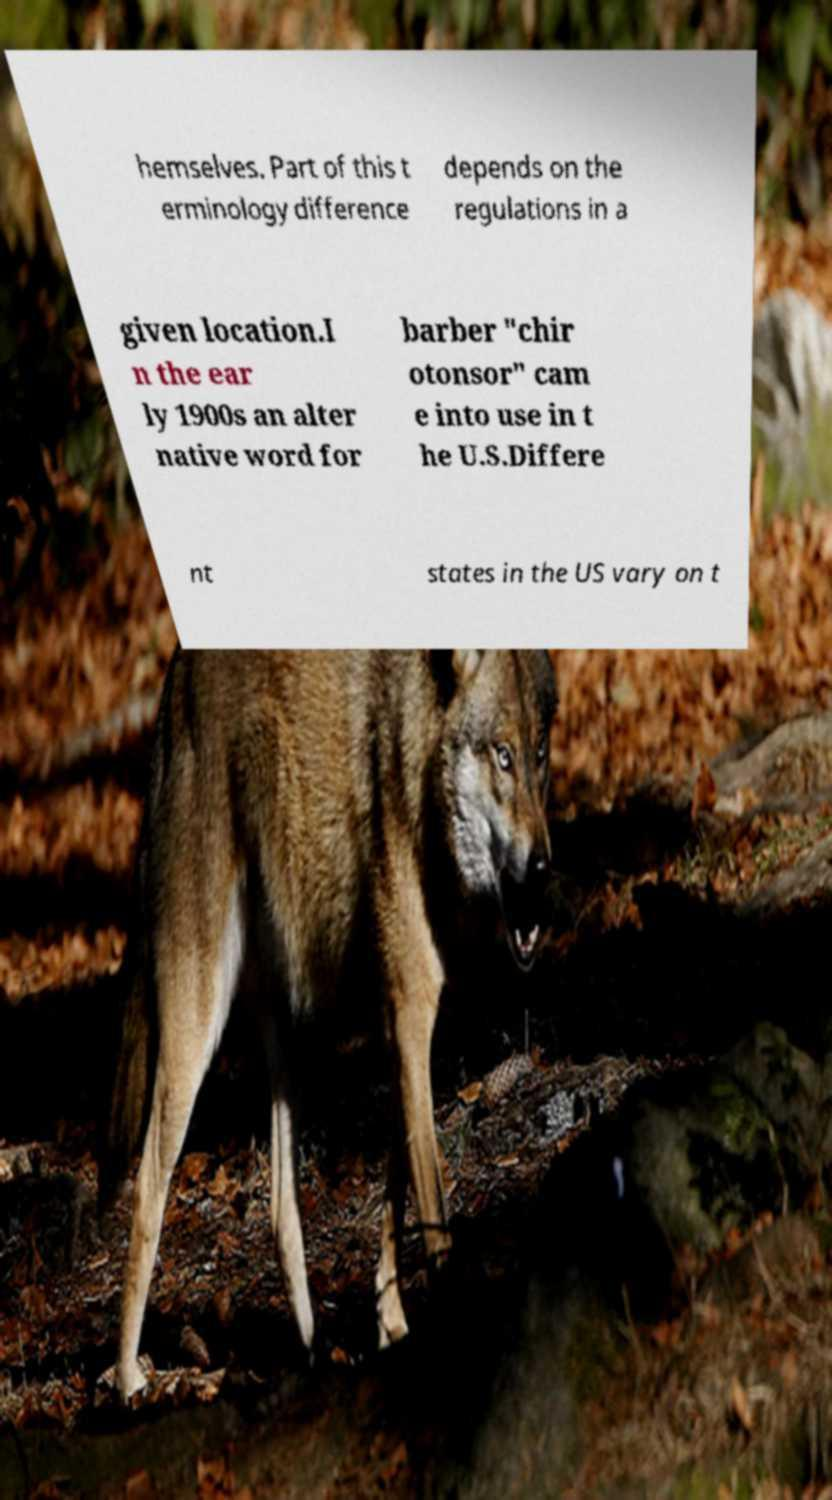Can you accurately transcribe the text from the provided image for me? hemselves. Part of this t erminology difference depends on the regulations in a given location.I n the ear ly 1900s an alter native word for barber "chir otonsor" cam e into use in t he U.S.Differe nt states in the US vary on t 